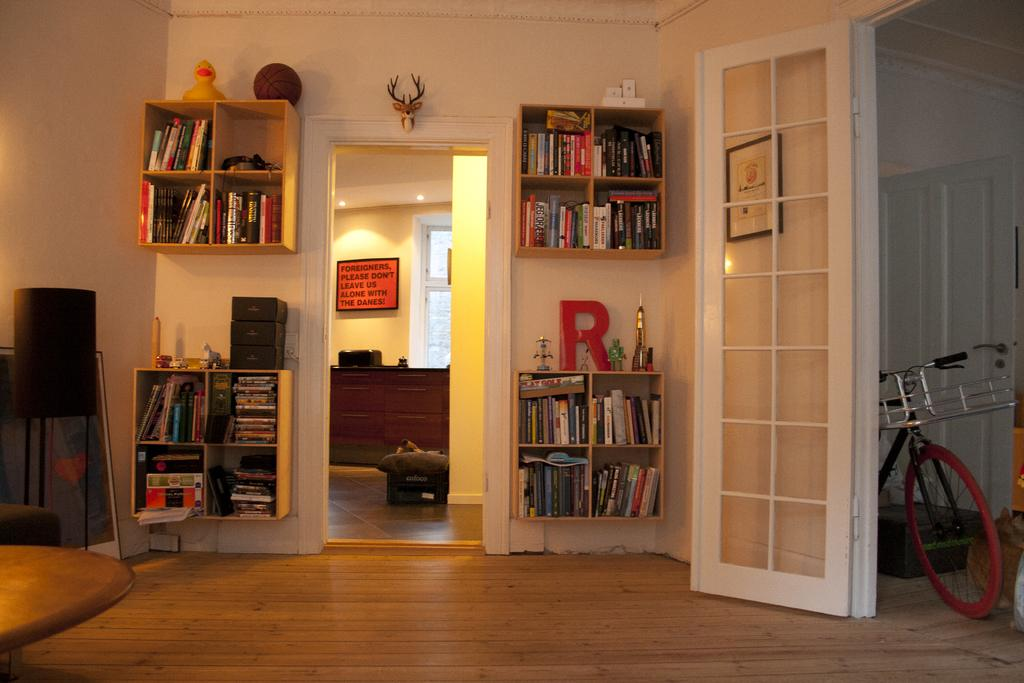<image>
Render a clear and concise summary of the photo. Some shelves are on a wall and one of them has the letter R on it. 